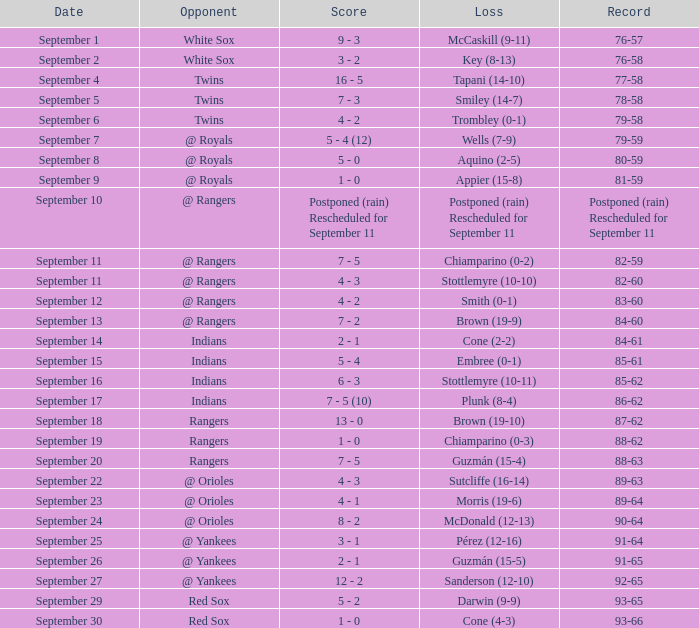Against which competitor did mccaskill secure a victory, given a 9-11 record? White Sox. 